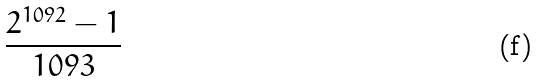<formula> <loc_0><loc_0><loc_500><loc_500>\frac { 2 ^ { 1 0 9 2 } - 1 } { 1 0 9 3 }</formula> 